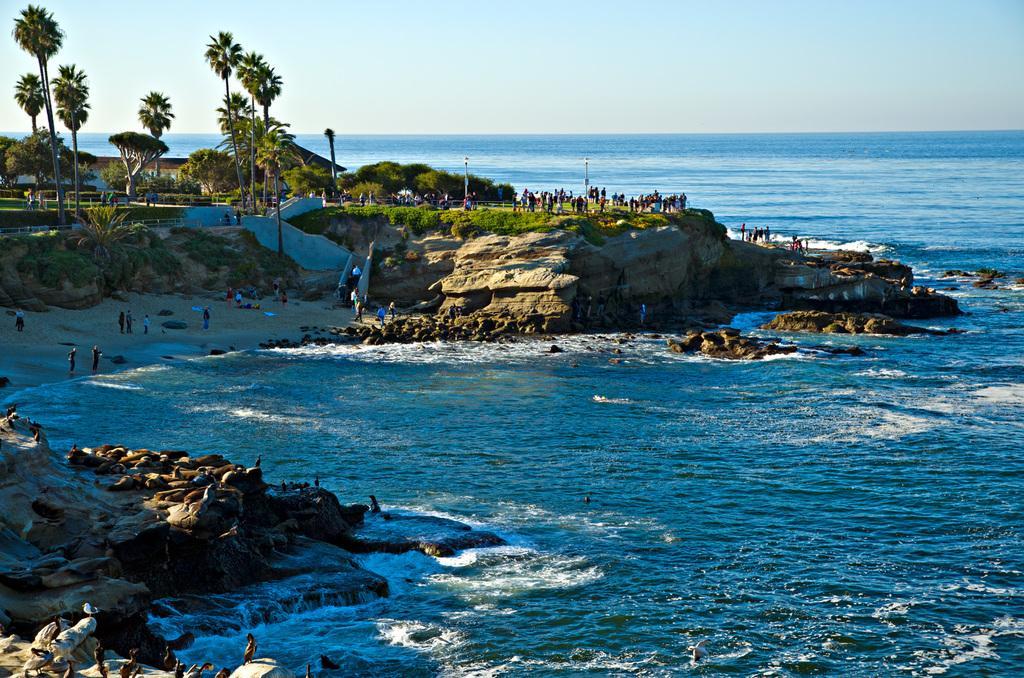Please provide a concise description of this image. In this picture we can see few people, water and few rocks, in the background we can find few trees, poles and houses. 